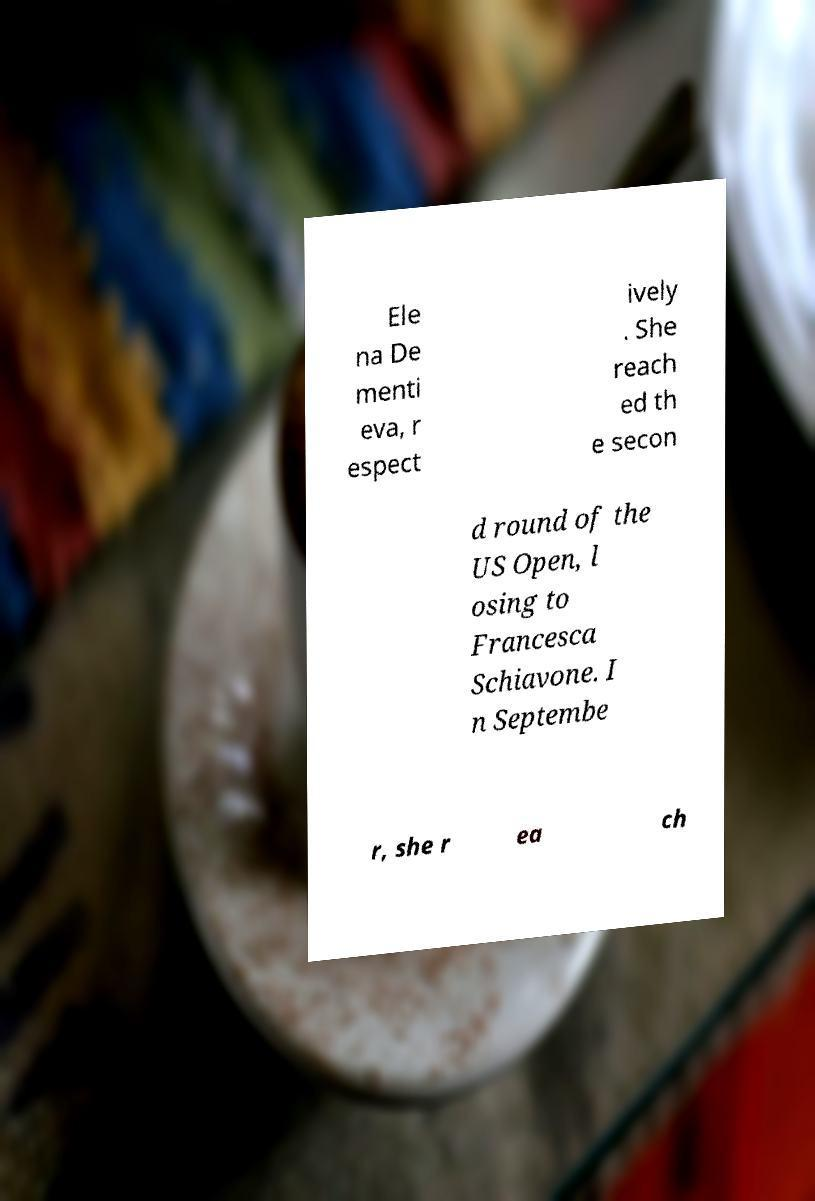Can you accurately transcribe the text from the provided image for me? Ele na De menti eva, r espect ively . She reach ed th e secon d round of the US Open, l osing to Francesca Schiavone. I n Septembe r, she r ea ch 